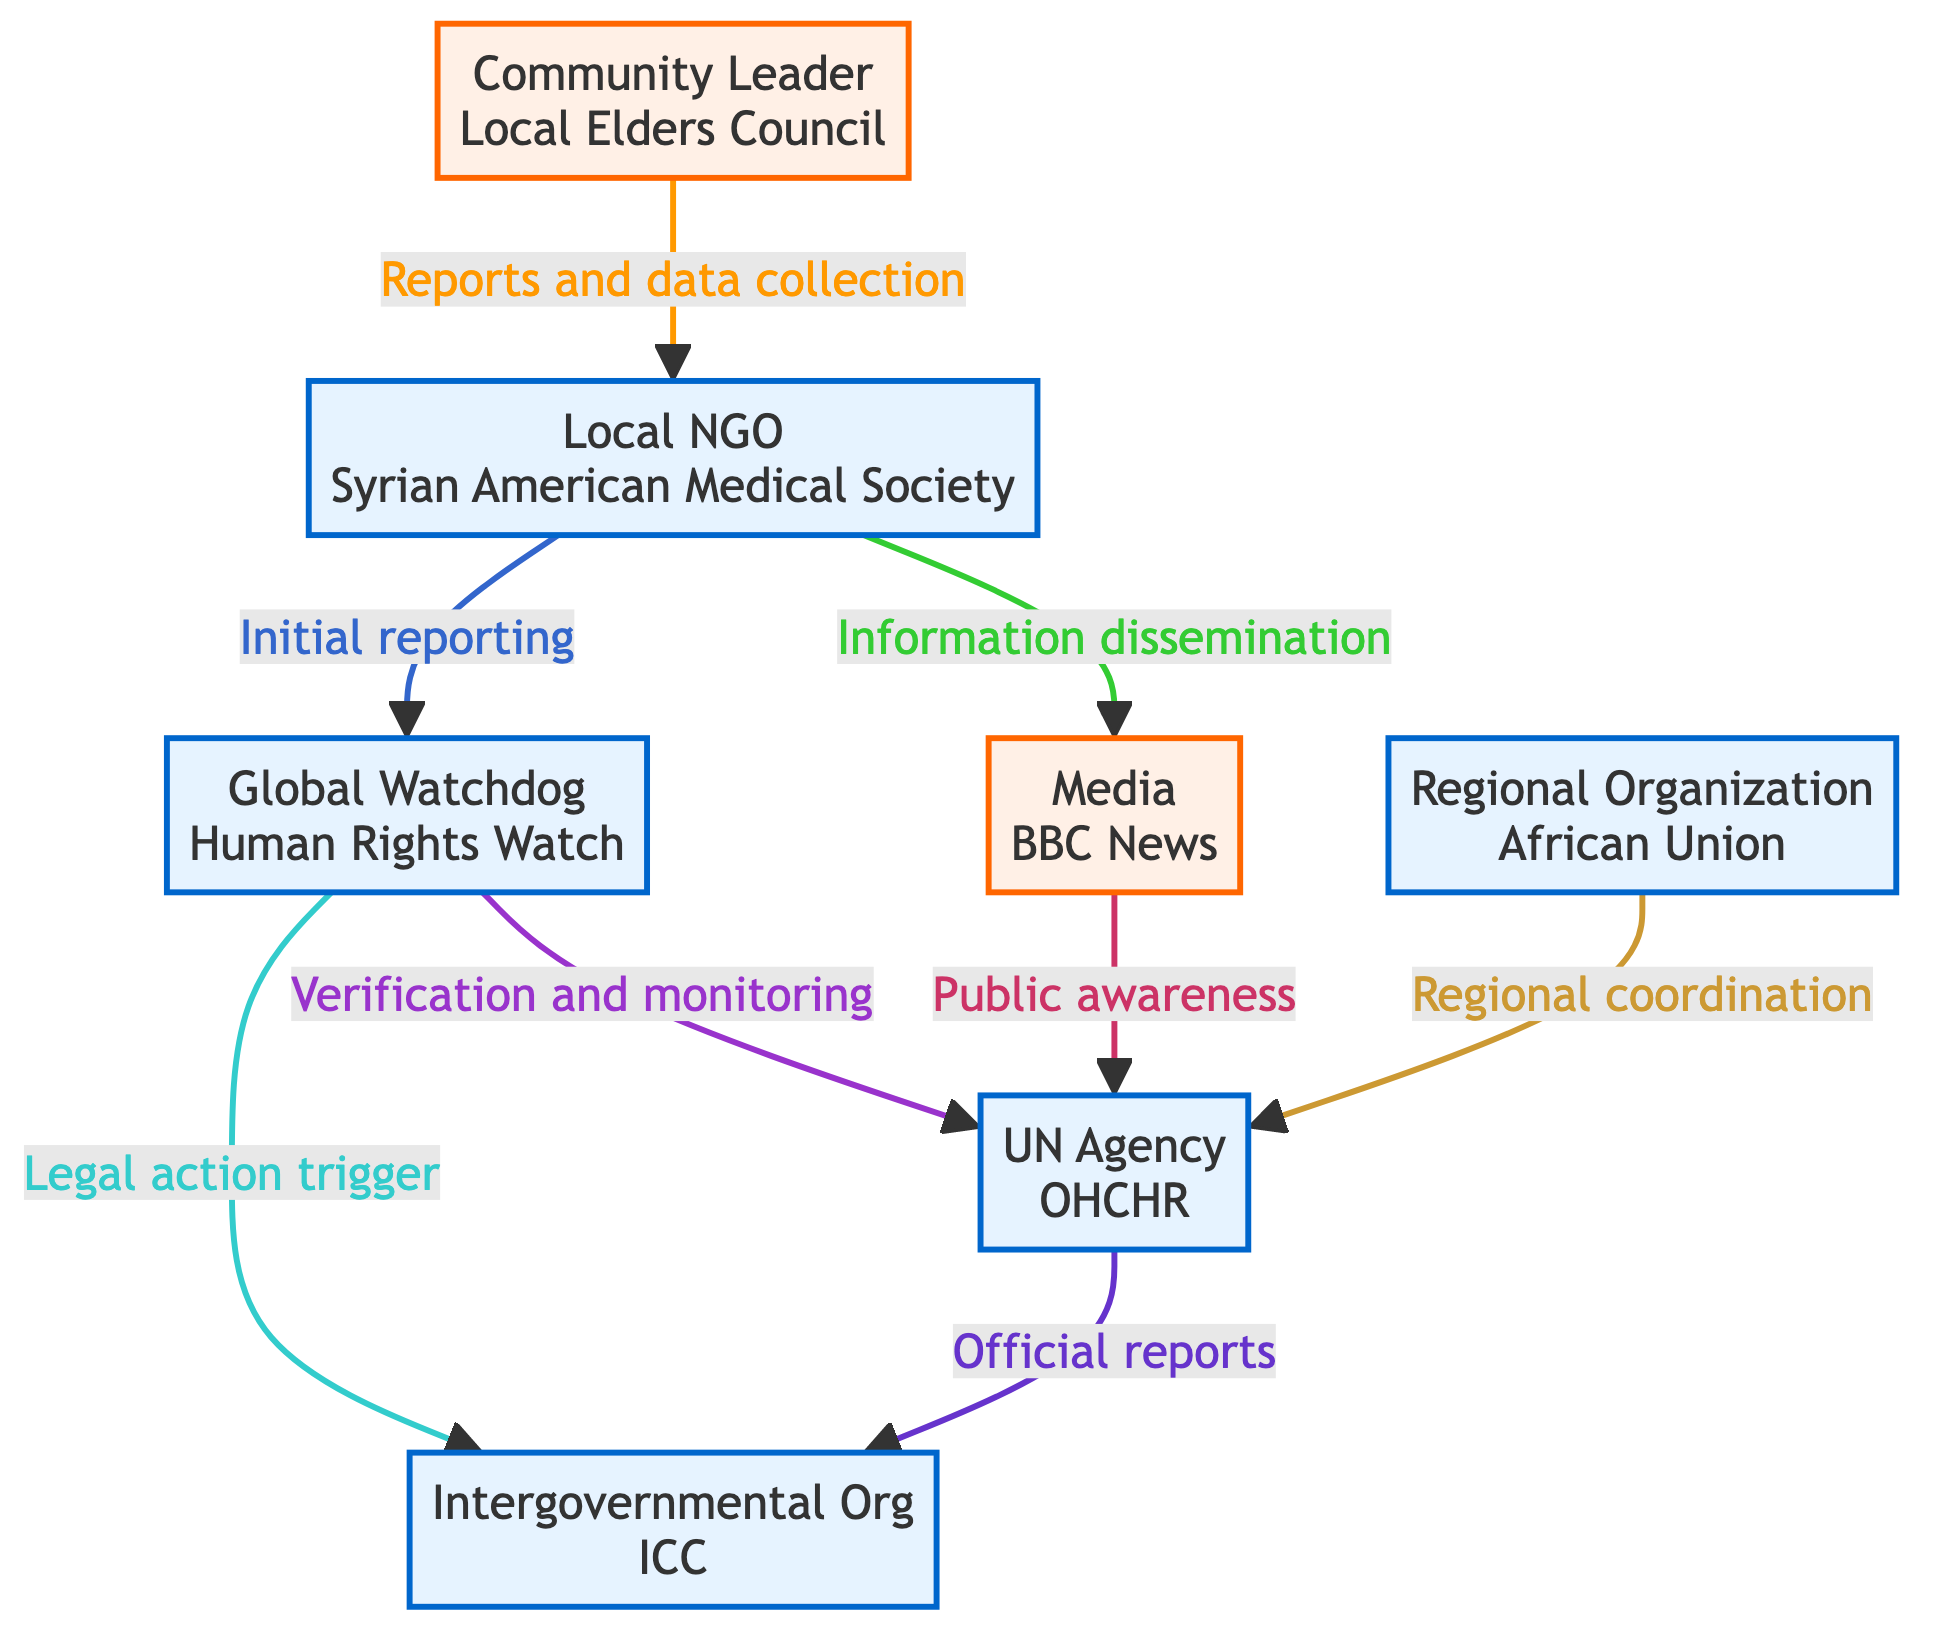What is the role of the Local NGO in this network? The Local NGO, represented by the Syrian American Medical Society, is responsible for the initial reporting of human rights violations and providing firsthand accounts.
Answer: Initial reporting of human rights violations, providing firsthand accounts How many nodes are there in the diagram? To determine the number of nodes, we count each unique entity represented, which totals to seven: Community Leader, Local NGO, Global Watchdog, Media, UN Agency, Intergovernmental Organization, and Regional Organization.
Answer: 7 Which organization communicates information to the Global Watchdog? The diagram shows that the Local NGO provides initial reporting to the Global Watchdog, which establishes a direct flow of information.
Answer: Local NGO What is the link between the Media and the UN Agency? The Media, represented by BBC News, disseminates information to the UN Agency through public awareness, indicating a communication pathway that raises awareness of issues concerning human rights violations.
Answer: Public awareness What type of action can the Intergovernmental Organization initiate? The Intergovernmental Organization, identified as the International Criminal Court, can initiate legal action based on verified human rights violation reports received from the Global Watchdog.
Answer: Legal action How many edges are present in the diagram? The total count of edges can be determined by identifying each connection between the nodes. There are eight edges indicating the flow of information and actions between the entities.
Answer: 8 What does the Community Leader provide to the Local NGO? The Community Leader, represented by the Local Elders Council, relays detailed accounts of local incidents, which facilitates the Local NGO's data collection on human rights violations.
Answer: Reports and data collection Which organization is responsible for final verification of human rights violations? The UN Agency, specifically the Office of the United Nations High Commissioner for Human Rights (OHCHR), is responsible for the final verification and documenting of human rights violations.
Answer: UN Agency What is the relationship between the Global Watchdog and the Intergovernmental Organization? The Global Watchdog provides evidence to the Intergovernmental Organization, which can serve as a trigger for initiating legal action based on the reports verified.
Answer: Legal action trigger 